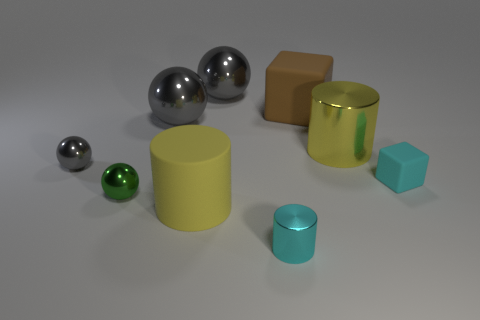Are there any other things that have the same material as the green thing? Yes, the small green sphere and the larger silver-colored sphere appear to be made of the same glossy material, indicating they may be composed of similar substances such as a polished metal or a synthetic with a metallic finish. 